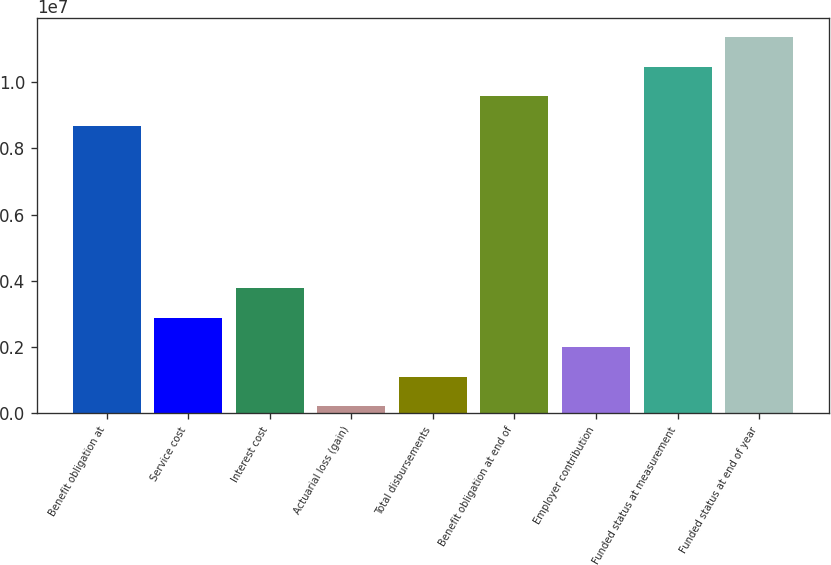Convert chart to OTSL. <chart><loc_0><loc_0><loc_500><loc_500><bar_chart><fcel>Benefit obligation at<fcel>Service cost<fcel>Interest cost<fcel>Actuarial loss (gain)<fcel>Total disbursements<fcel>Benefit obligation at end of<fcel>Employer contribution<fcel>Funded status at measurement<fcel>Funded status at end of year<nl><fcel>8.675e+06<fcel>2.8928e+06<fcel>3.7874e+06<fcel>209000<fcel>1.1036e+06<fcel>9.5696e+06<fcel>1.9982e+06<fcel>1.04642e+07<fcel>1.13588e+07<nl></chart> 